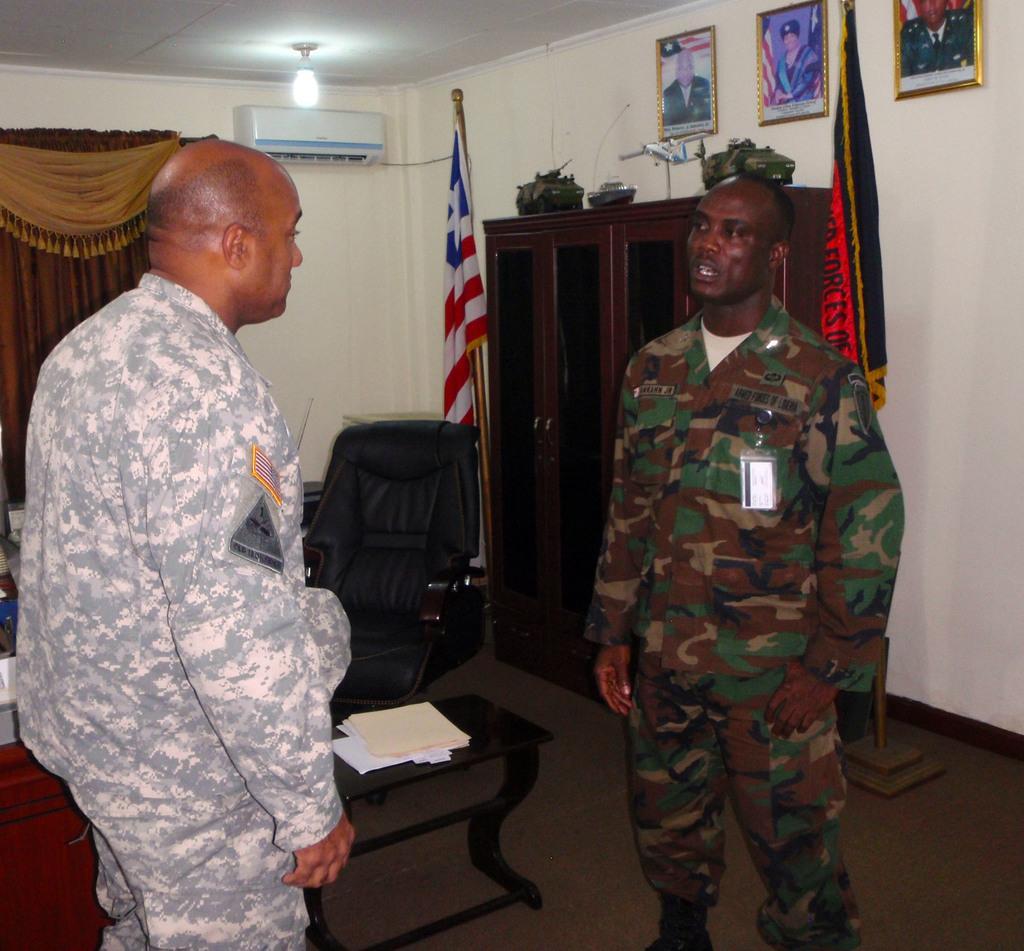Please provide a concise description of this image. In this image there are two persons who are standing and on the left side there is one chair beside that chair there is one table. On that table there are some papers and on the background there is wall and on the wall there is one air conditioner and some photo frames are there and on the right side there is one cupboard, beside that cupboard there is one flag and on the top there is ceiling on the ceiling there is one light and on the top of the left side there is one curtain. 